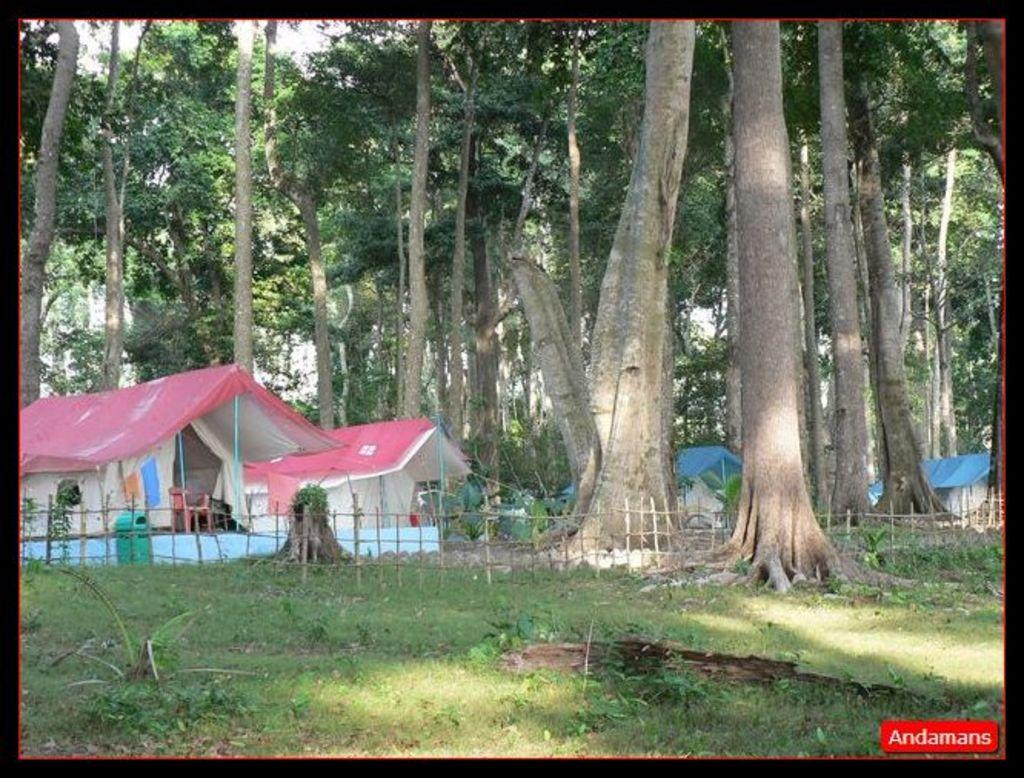What can be seen in the middle of the image? There are trees, tents, a fence, plants, clothes, a chair, a dustbin, and text in the middle of the image. What is the background of the image? The sky is visible in the image. Can you see a self in the image? There is no self or person present in the image. What type of fan is visible in the image? There is no fan present in the image. 